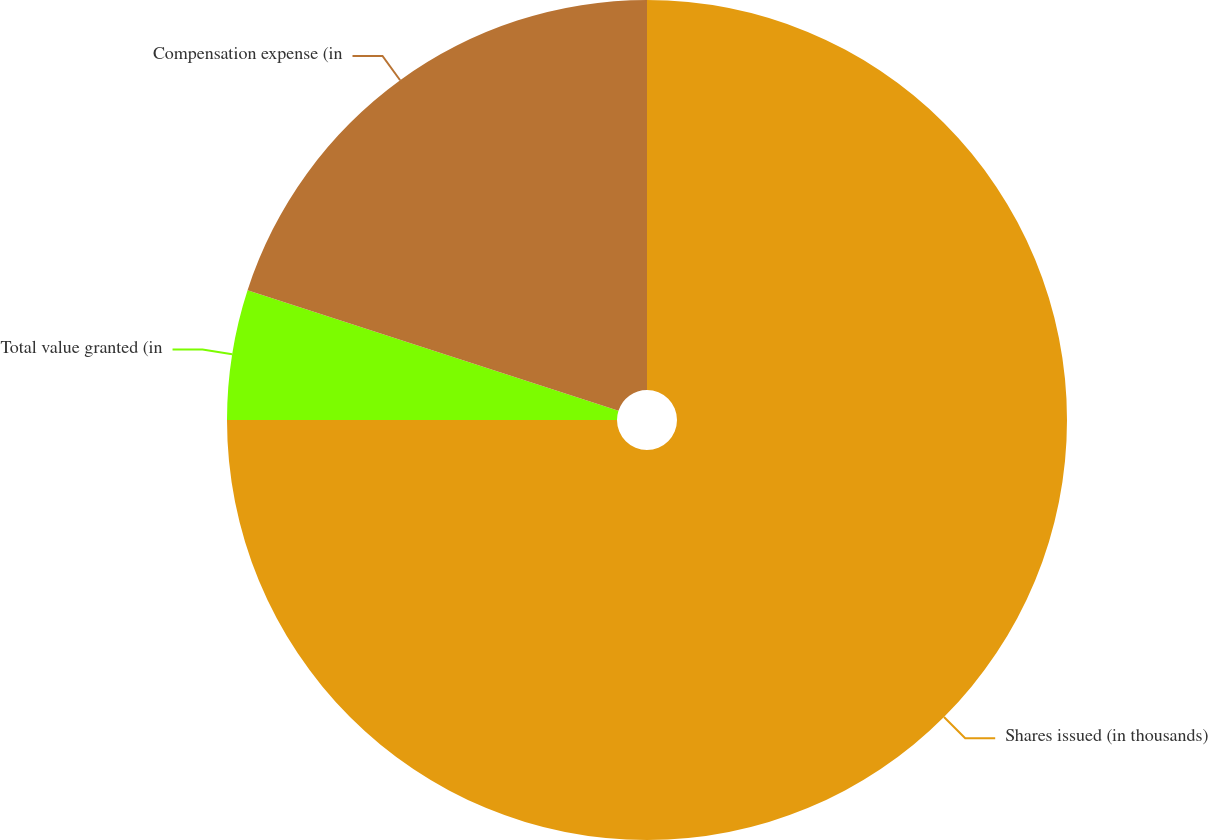Convert chart. <chart><loc_0><loc_0><loc_500><loc_500><pie_chart><fcel>Shares issued (in thousands)<fcel>Total value granted (in<fcel>Compensation expense (in<nl><fcel>75.0%<fcel>5.0%<fcel>20.0%<nl></chart> 